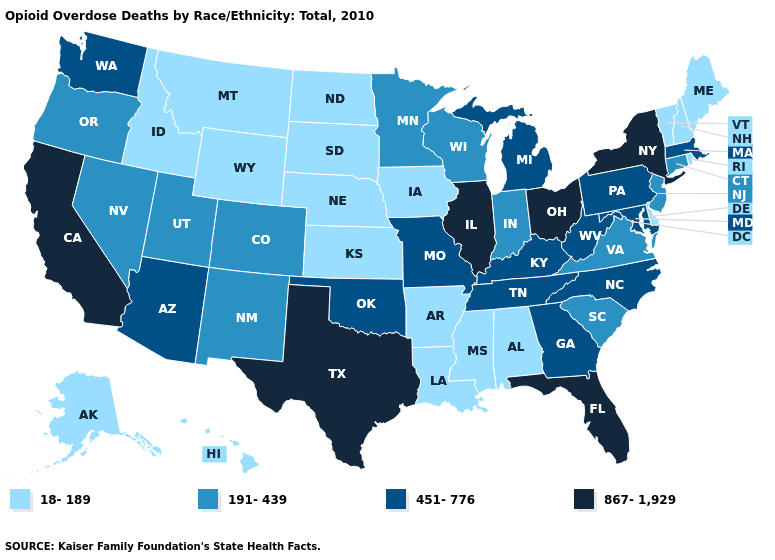Is the legend a continuous bar?
Answer briefly. No. What is the value of Idaho?
Concise answer only. 18-189. What is the lowest value in the South?
Write a very short answer. 18-189. What is the value of Idaho?
Quick response, please. 18-189. What is the lowest value in states that border Minnesota?
Short answer required. 18-189. Does Georgia have the lowest value in the South?
Answer briefly. No. What is the lowest value in the MidWest?
Give a very brief answer. 18-189. Which states have the highest value in the USA?
Give a very brief answer. California, Florida, Illinois, New York, Ohio, Texas. What is the value of Illinois?
Keep it brief. 867-1,929. What is the highest value in the USA?
Give a very brief answer. 867-1,929. Name the states that have a value in the range 191-439?
Keep it brief. Colorado, Connecticut, Indiana, Minnesota, Nevada, New Jersey, New Mexico, Oregon, South Carolina, Utah, Virginia, Wisconsin. Among the states that border Iowa , does Minnesota have the lowest value?
Short answer required. No. Does Iowa have the highest value in the USA?
Answer briefly. No. Which states have the lowest value in the USA?
Give a very brief answer. Alabama, Alaska, Arkansas, Delaware, Hawaii, Idaho, Iowa, Kansas, Louisiana, Maine, Mississippi, Montana, Nebraska, New Hampshire, North Dakota, Rhode Island, South Dakota, Vermont, Wyoming. Name the states that have a value in the range 451-776?
Keep it brief. Arizona, Georgia, Kentucky, Maryland, Massachusetts, Michigan, Missouri, North Carolina, Oklahoma, Pennsylvania, Tennessee, Washington, West Virginia. 